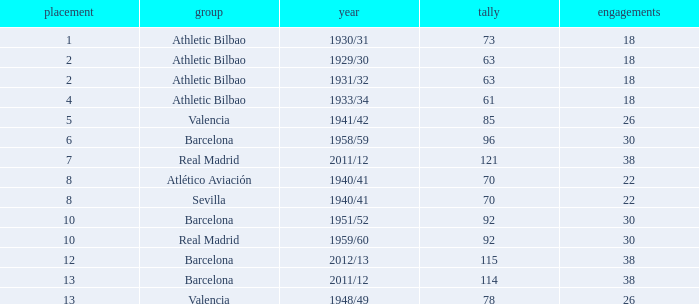Who was the club having less than 22 apps and ranked less than 2? Athletic Bilbao. 